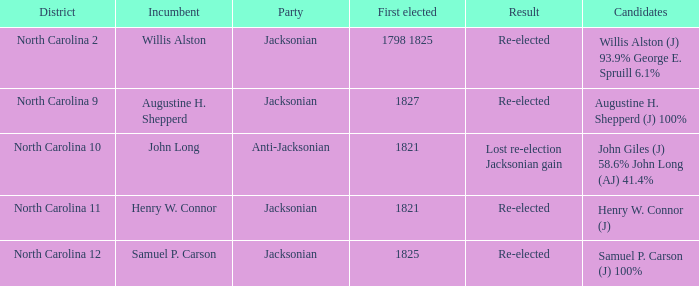What is the district known for its opposition to jacksonian policies? North Carolina 10. 